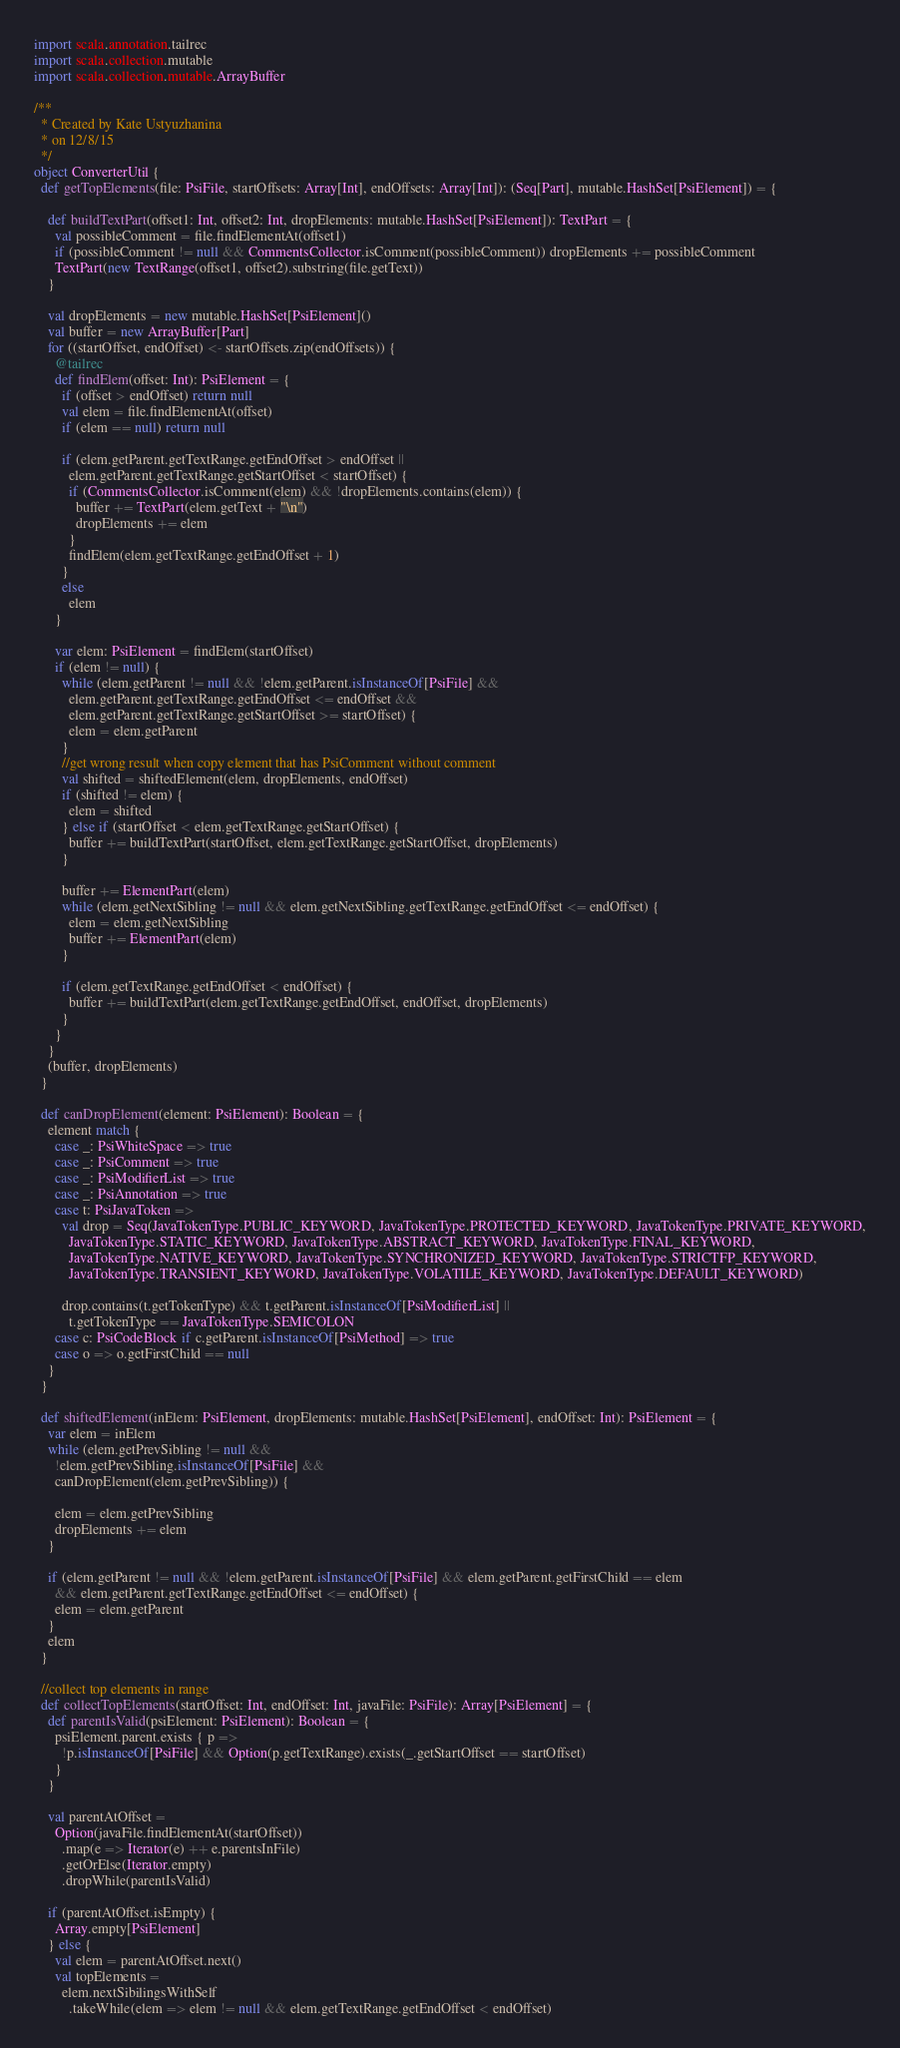Convert code to text. <code><loc_0><loc_0><loc_500><loc_500><_Scala_>import scala.annotation.tailrec
import scala.collection.mutable
import scala.collection.mutable.ArrayBuffer

/**
  * Created by Kate Ustyuzhanina
  * on 12/8/15
  */
object ConverterUtil {
  def getTopElements(file: PsiFile, startOffsets: Array[Int], endOffsets: Array[Int]): (Seq[Part], mutable.HashSet[PsiElement]) = {

    def buildTextPart(offset1: Int, offset2: Int, dropElements: mutable.HashSet[PsiElement]): TextPart = {
      val possibleComment = file.findElementAt(offset1)
      if (possibleComment != null && CommentsCollector.isComment(possibleComment)) dropElements += possibleComment
      TextPart(new TextRange(offset1, offset2).substring(file.getText))
    }

    val dropElements = new mutable.HashSet[PsiElement]()
    val buffer = new ArrayBuffer[Part]
    for ((startOffset, endOffset) <- startOffsets.zip(endOffsets)) {
      @tailrec
      def findElem(offset: Int): PsiElement = {
        if (offset > endOffset) return null
        val elem = file.findElementAt(offset)
        if (elem == null) return null

        if (elem.getParent.getTextRange.getEndOffset > endOffset ||
          elem.getParent.getTextRange.getStartOffset < startOffset) {
          if (CommentsCollector.isComment(elem) && !dropElements.contains(elem)) {
            buffer += TextPart(elem.getText + "\n")
            dropElements += elem
          }
          findElem(elem.getTextRange.getEndOffset + 1)
        }
        else
          elem
      }

      var elem: PsiElement = findElem(startOffset)
      if (elem != null) {
        while (elem.getParent != null && !elem.getParent.isInstanceOf[PsiFile] &&
          elem.getParent.getTextRange.getEndOffset <= endOffset &&
          elem.getParent.getTextRange.getStartOffset >= startOffset) {
          elem = elem.getParent
        }
        //get wrong result when copy element that has PsiComment without comment
        val shifted = shiftedElement(elem, dropElements, endOffset)
        if (shifted != elem) {
          elem = shifted
        } else if (startOffset < elem.getTextRange.getStartOffset) {
          buffer += buildTextPart(startOffset, elem.getTextRange.getStartOffset, dropElements)
        }

        buffer += ElementPart(elem)
        while (elem.getNextSibling != null && elem.getNextSibling.getTextRange.getEndOffset <= endOffset) {
          elem = elem.getNextSibling
          buffer += ElementPart(elem)
        }

        if (elem.getTextRange.getEndOffset < endOffset) {
          buffer += buildTextPart(elem.getTextRange.getEndOffset, endOffset, dropElements)
        }
      }
    }
    (buffer, dropElements)
  }

  def canDropElement(element: PsiElement): Boolean = {
    element match {
      case _: PsiWhiteSpace => true
      case _: PsiComment => true
      case _: PsiModifierList => true
      case _: PsiAnnotation => true
      case t: PsiJavaToken =>
        val drop = Seq(JavaTokenType.PUBLIC_KEYWORD, JavaTokenType.PROTECTED_KEYWORD, JavaTokenType.PRIVATE_KEYWORD,
          JavaTokenType.STATIC_KEYWORD, JavaTokenType.ABSTRACT_KEYWORD, JavaTokenType.FINAL_KEYWORD,
          JavaTokenType.NATIVE_KEYWORD, JavaTokenType.SYNCHRONIZED_KEYWORD, JavaTokenType.STRICTFP_KEYWORD,
          JavaTokenType.TRANSIENT_KEYWORD, JavaTokenType.VOLATILE_KEYWORD, JavaTokenType.DEFAULT_KEYWORD)

        drop.contains(t.getTokenType) && t.getParent.isInstanceOf[PsiModifierList] ||
          t.getTokenType == JavaTokenType.SEMICOLON
      case c: PsiCodeBlock if c.getParent.isInstanceOf[PsiMethod] => true
      case o => o.getFirstChild == null
    }
  }

  def shiftedElement(inElem: PsiElement, dropElements: mutable.HashSet[PsiElement], endOffset: Int): PsiElement = {
    var elem = inElem
    while (elem.getPrevSibling != null &&
      !elem.getPrevSibling.isInstanceOf[PsiFile] &&
      canDropElement(elem.getPrevSibling)) {

      elem = elem.getPrevSibling
      dropElements += elem
    }

    if (elem.getParent != null && !elem.getParent.isInstanceOf[PsiFile] && elem.getParent.getFirstChild == elem
      && elem.getParent.getTextRange.getEndOffset <= endOffset) {
      elem = elem.getParent
    }
    elem
  }

  //collect top elements in range
  def collectTopElements(startOffset: Int, endOffset: Int, javaFile: PsiFile): Array[PsiElement] = {
    def parentIsValid(psiElement: PsiElement): Boolean = {
      psiElement.parent.exists { p =>
        !p.isInstanceOf[PsiFile] && Option(p.getTextRange).exists(_.getStartOffset == startOffset)
      }
    }

    val parentAtOffset =
      Option(javaFile.findElementAt(startOffset))
        .map(e => Iterator(e) ++ e.parentsInFile)
        .getOrElse(Iterator.empty)
        .dropWhile(parentIsValid)

    if (parentAtOffset.isEmpty) {
      Array.empty[PsiElement]
    } else {
      val elem = parentAtOffset.next()
      val topElements =
        elem.nextSibilingsWithSelf
          .takeWhile(elem => elem != null && elem.getTextRange.getEndOffset < endOffset)</code> 